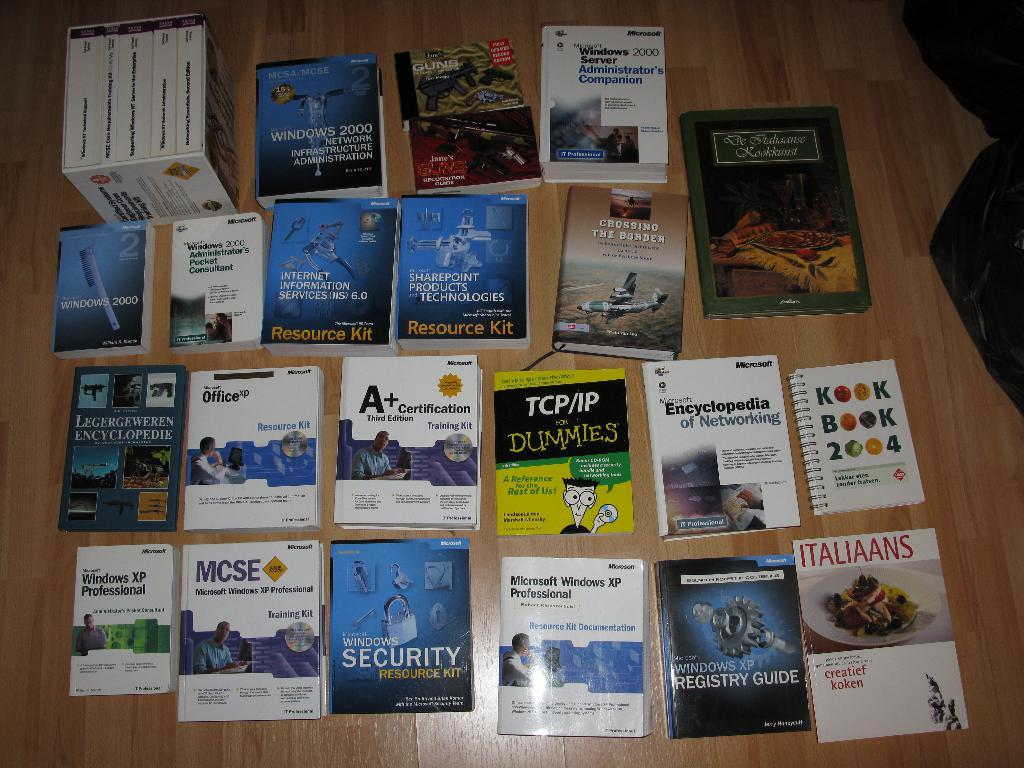<image>
Relay a brief, clear account of the picture shown. A spread of books including TCP/IP for Dummies 